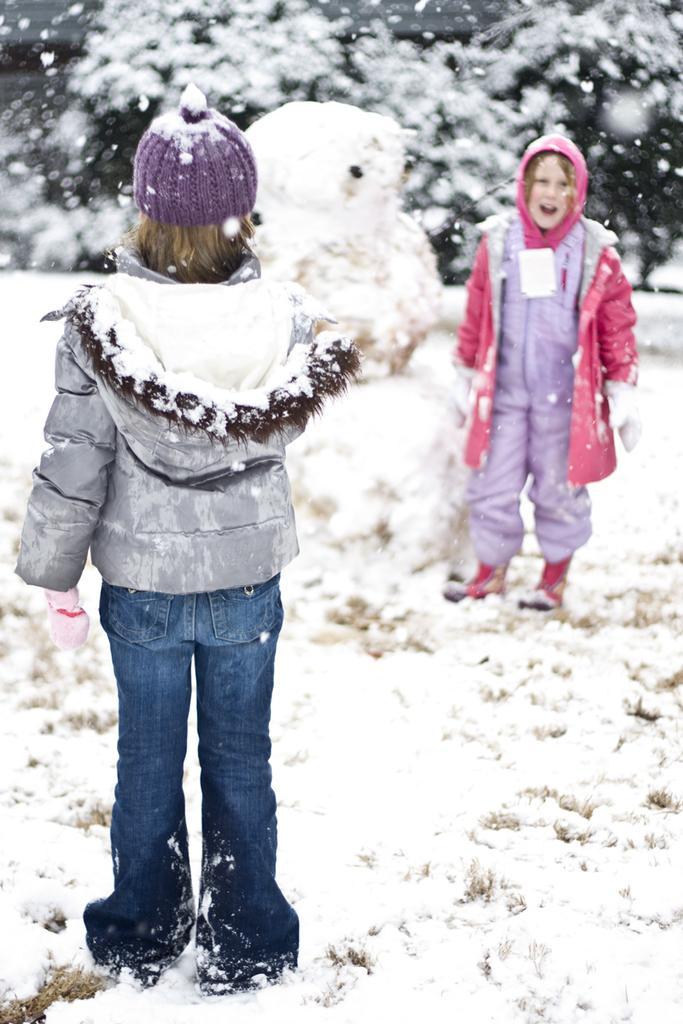Describe this image in one or two sentences. In this image I can see two persons are standing on the road, snow ice and trees. This image is taken may be during a day. 